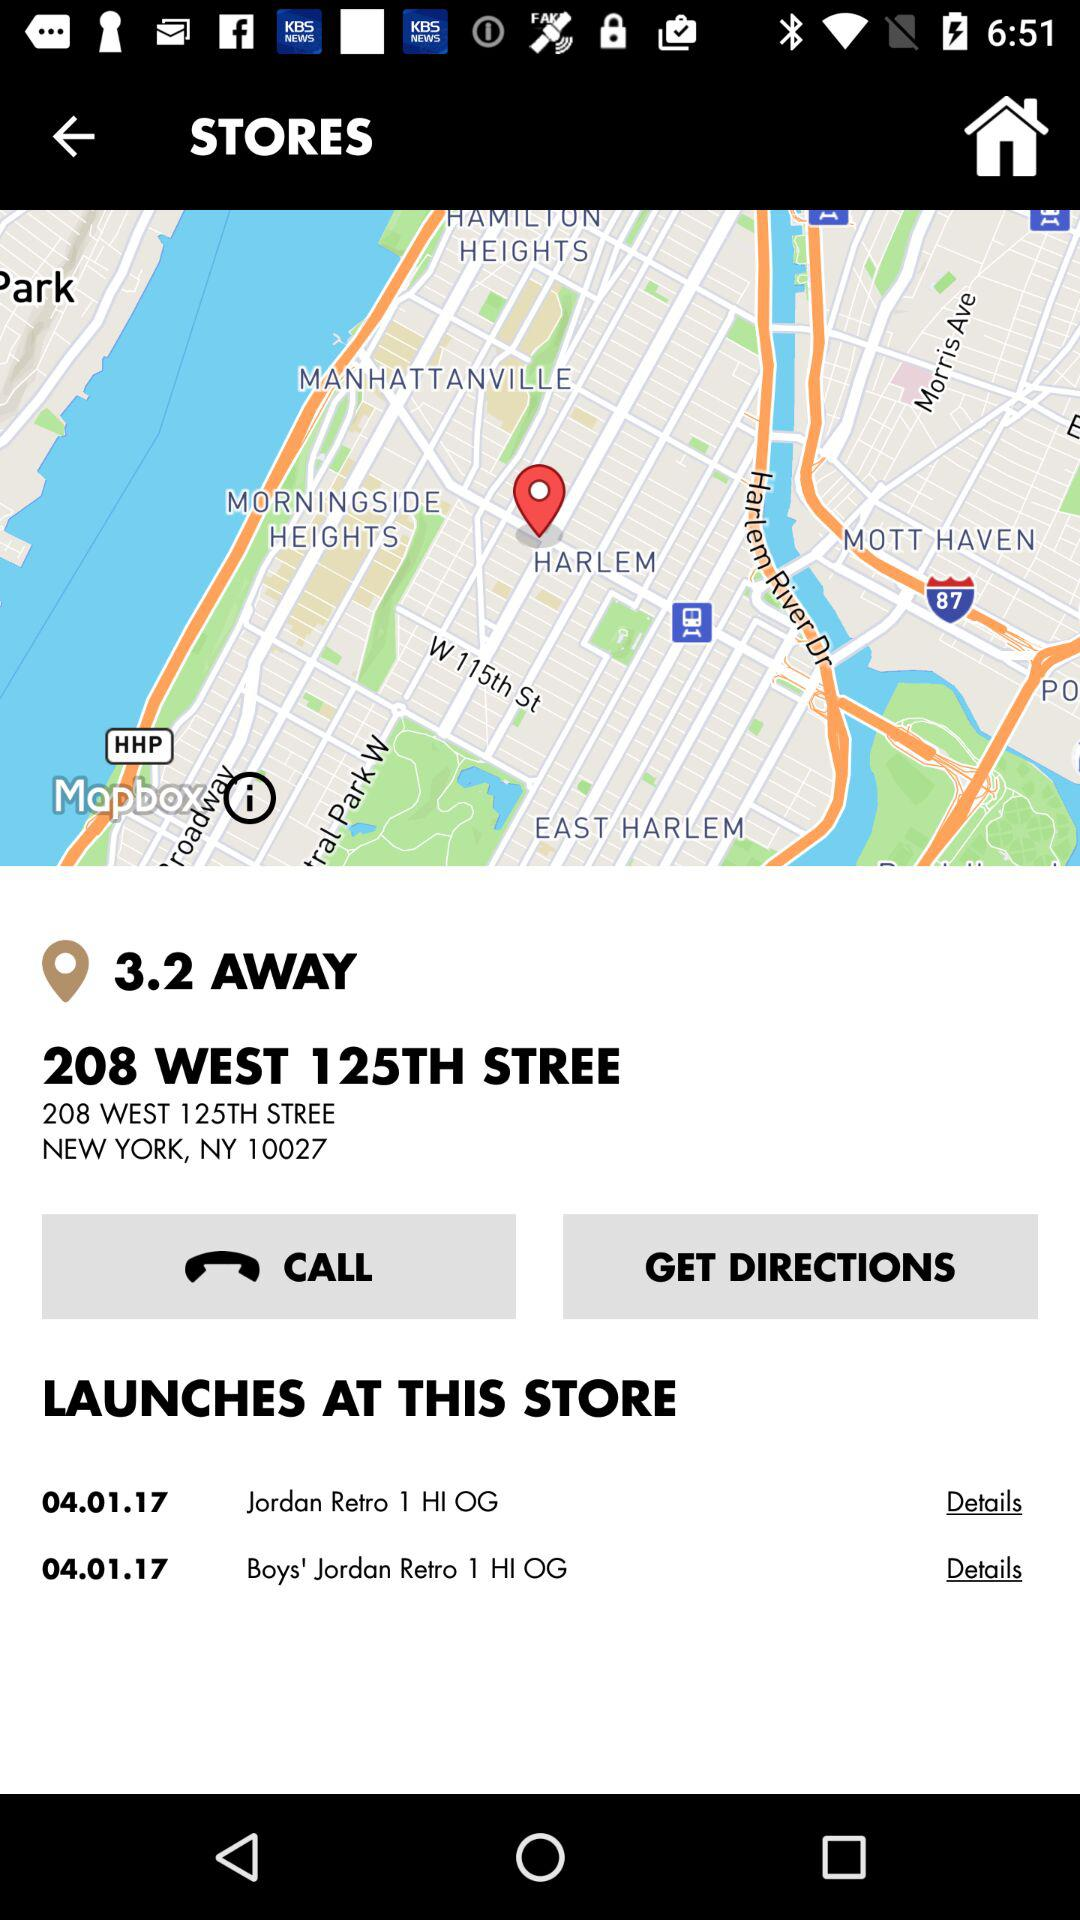What is the shown distance? The shown distance is 3.2. 